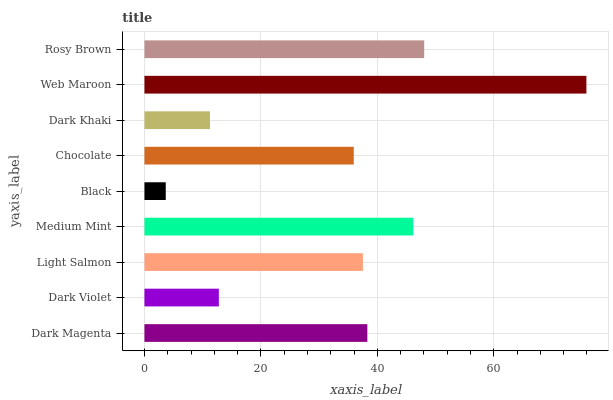Is Black the minimum?
Answer yes or no. Yes. Is Web Maroon the maximum?
Answer yes or no. Yes. Is Dark Violet the minimum?
Answer yes or no. No. Is Dark Violet the maximum?
Answer yes or no. No. Is Dark Magenta greater than Dark Violet?
Answer yes or no. Yes. Is Dark Violet less than Dark Magenta?
Answer yes or no. Yes. Is Dark Violet greater than Dark Magenta?
Answer yes or no. No. Is Dark Magenta less than Dark Violet?
Answer yes or no. No. Is Light Salmon the high median?
Answer yes or no. Yes. Is Light Salmon the low median?
Answer yes or no. Yes. Is Medium Mint the high median?
Answer yes or no. No. Is Medium Mint the low median?
Answer yes or no. No. 